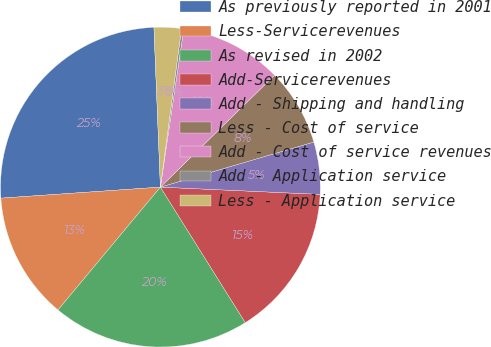Convert chart to OTSL. <chart><loc_0><loc_0><loc_500><loc_500><pie_chart><fcel>As previously reported in 2001<fcel>Less-Servicerevenues<fcel>As revised in 2002<fcel>Add-Servicerevenues<fcel>Add - Shipping and handling<fcel>Less - Cost of service<fcel>Add - Cost of service revenues<fcel>Add - Application service<fcel>Less - Application service<nl><fcel>25.46%<fcel>12.84%<fcel>19.97%<fcel>15.37%<fcel>5.27%<fcel>7.8%<fcel>10.32%<fcel>0.23%<fcel>2.75%<nl></chart> 